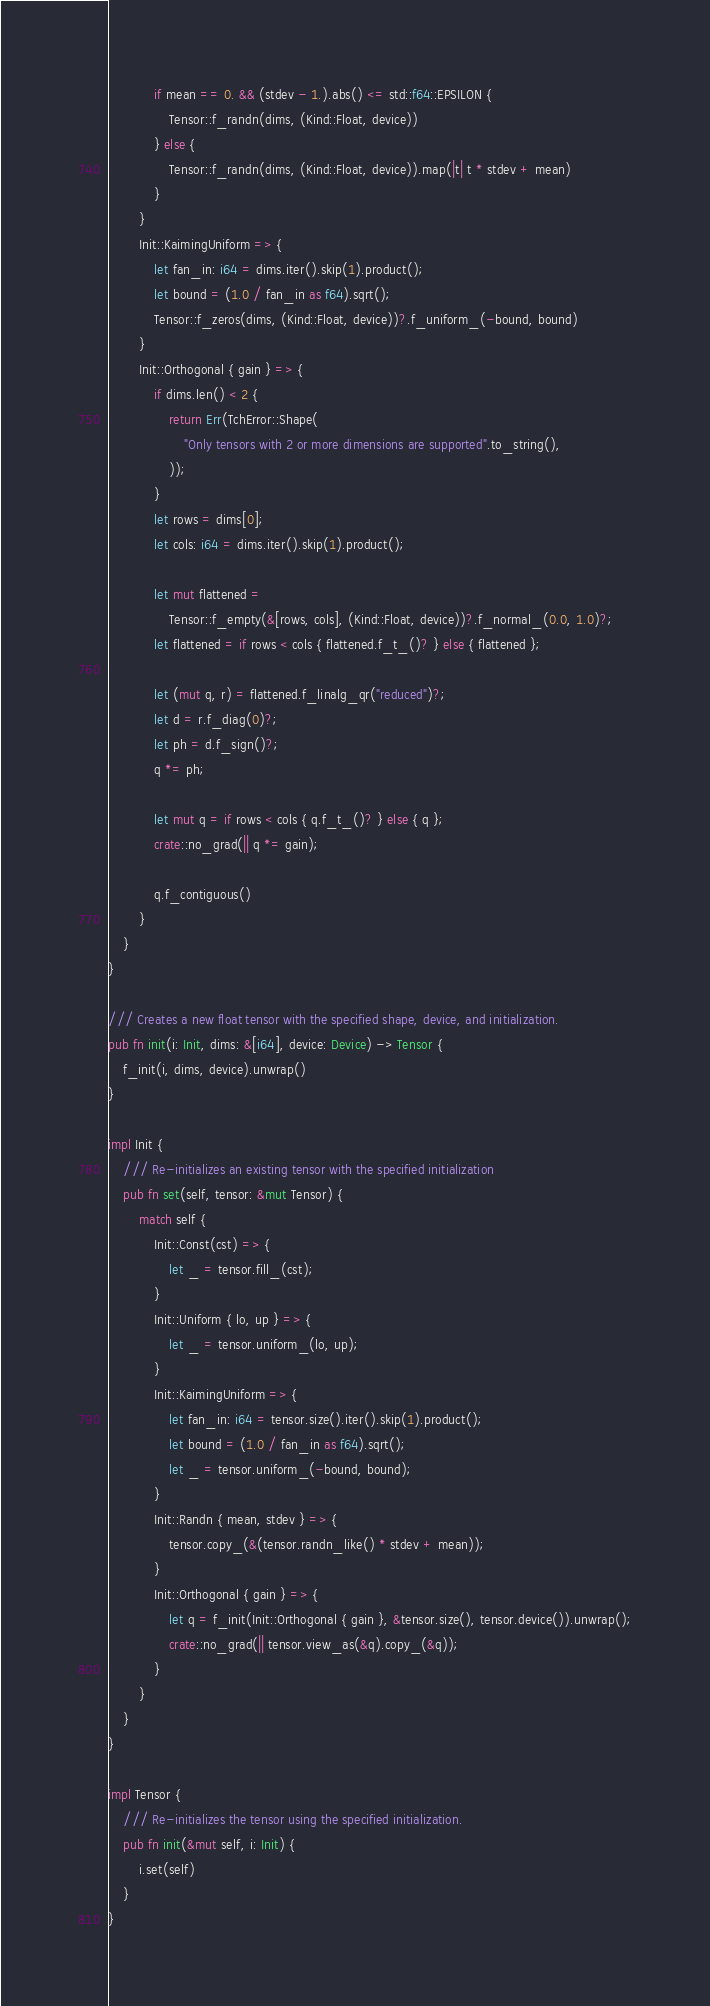Convert code to text. <code><loc_0><loc_0><loc_500><loc_500><_Rust_>            if mean == 0. && (stdev - 1.).abs() <= std::f64::EPSILON {
                Tensor::f_randn(dims, (Kind::Float, device))
            } else {
                Tensor::f_randn(dims, (Kind::Float, device)).map(|t| t * stdev + mean)
            }
        }
        Init::KaimingUniform => {
            let fan_in: i64 = dims.iter().skip(1).product();
            let bound = (1.0 / fan_in as f64).sqrt();
            Tensor::f_zeros(dims, (Kind::Float, device))?.f_uniform_(-bound, bound)
        }
        Init::Orthogonal { gain } => {
            if dims.len() < 2 {
                return Err(TchError::Shape(
                    "Only tensors with 2 or more dimensions are supported".to_string(),
                ));
            }
            let rows = dims[0];
            let cols: i64 = dims.iter().skip(1).product();

            let mut flattened =
                Tensor::f_empty(&[rows, cols], (Kind::Float, device))?.f_normal_(0.0, 1.0)?;
            let flattened = if rows < cols { flattened.f_t_()? } else { flattened };

            let (mut q, r) = flattened.f_linalg_qr("reduced")?;
            let d = r.f_diag(0)?;
            let ph = d.f_sign()?;
            q *= ph;

            let mut q = if rows < cols { q.f_t_()? } else { q };
            crate::no_grad(|| q *= gain);

            q.f_contiguous()
        }
    }
}

/// Creates a new float tensor with the specified shape, device, and initialization.
pub fn init(i: Init, dims: &[i64], device: Device) -> Tensor {
    f_init(i, dims, device).unwrap()
}

impl Init {
    /// Re-initializes an existing tensor with the specified initialization
    pub fn set(self, tensor: &mut Tensor) {
        match self {
            Init::Const(cst) => {
                let _ = tensor.fill_(cst);
            }
            Init::Uniform { lo, up } => {
                let _ = tensor.uniform_(lo, up);
            }
            Init::KaimingUniform => {
                let fan_in: i64 = tensor.size().iter().skip(1).product();
                let bound = (1.0 / fan_in as f64).sqrt();
                let _ = tensor.uniform_(-bound, bound);
            }
            Init::Randn { mean, stdev } => {
                tensor.copy_(&(tensor.randn_like() * stdev + mean));
            }
            Init::Orthogonal { gain } => {
                let q = f_init(Init::Orthogonal { gain }, &tensor.size(), tensor.device()).unwrap();
                crate::no_grad(|| tensor.view_as(&q).copy_(&q));
            }
        }
    }
}

impl Tensor {
    /// Re-initializes the tensor using the specified initialization.
    pub fn init(&mut self, i: Init) {
        i.set(self)
    }
}
</code> 